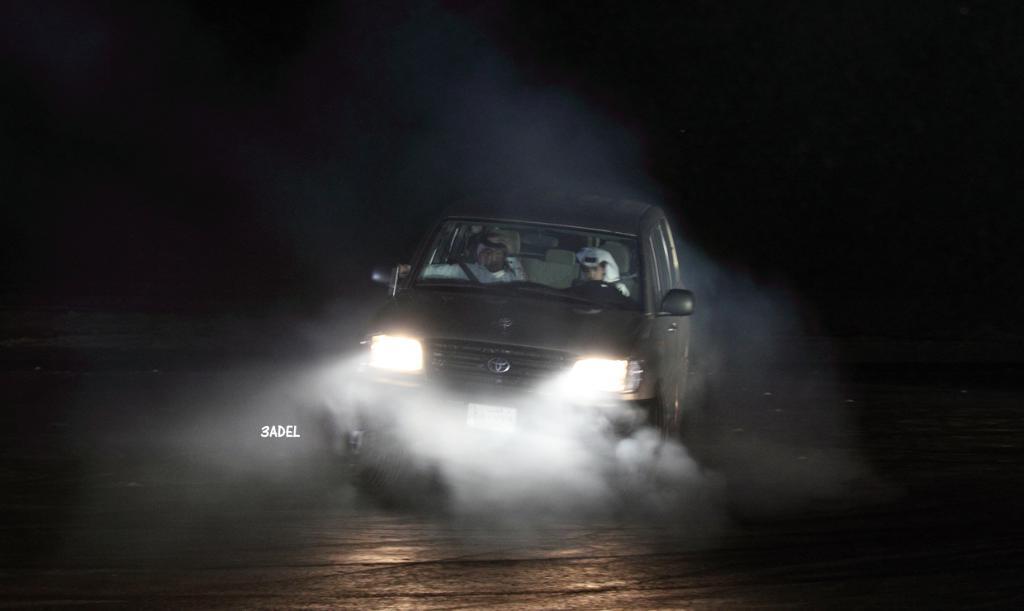How would you summarize this image in a sentence or two? In this image, in the middle, we can see a car moving on the road. In the car, we can see two people. In the background, we can see black color. At the bottom, we can see a road. 